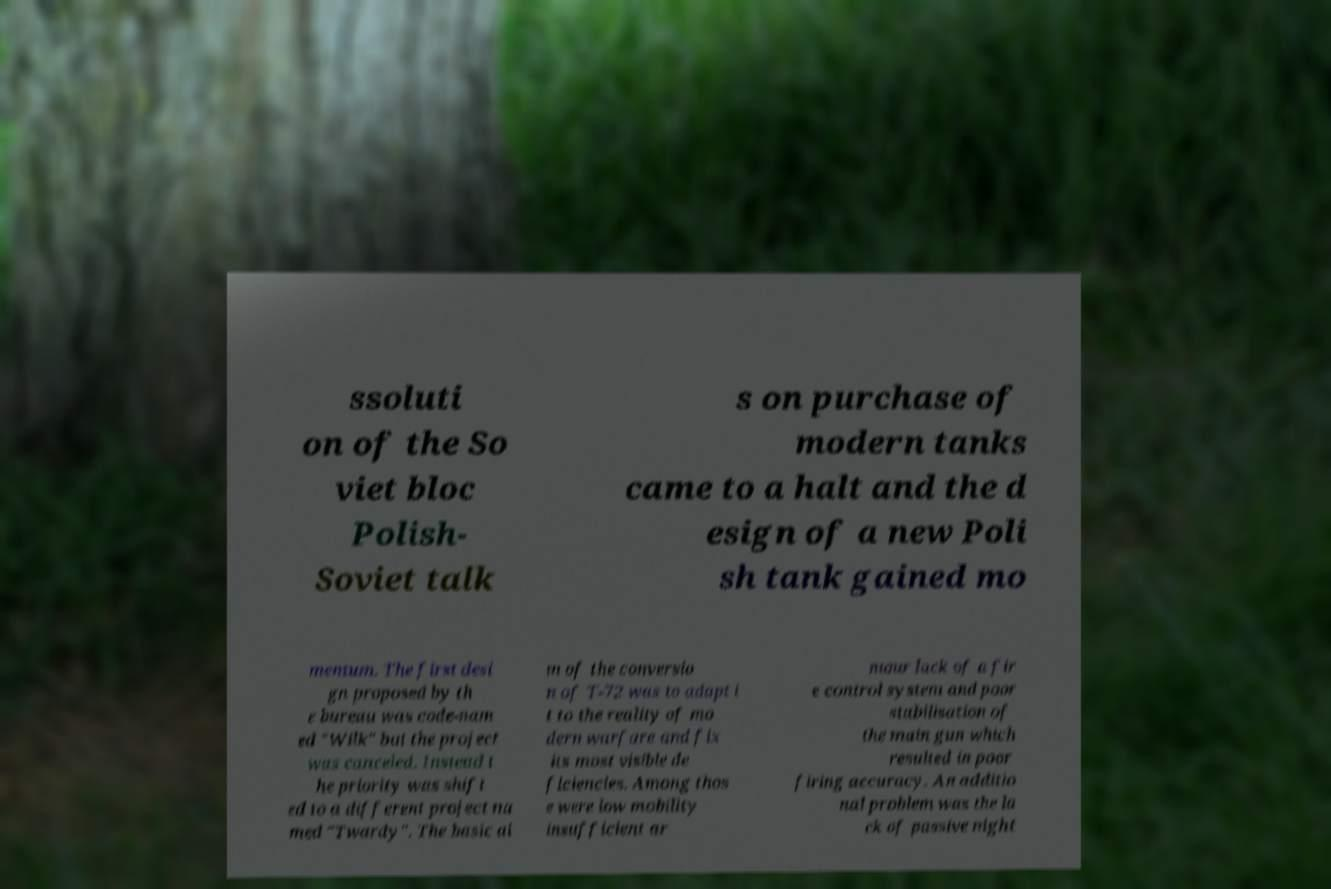Can you accurately transcribe the text from the provided image for me? ssoluti on of the So viet bloc Polish- Soviet talk s on purchase of modern tanks came to a halt and the d esign of a new Poli sh tank gained mo mentum. The first desi gn proposed by th e bureau was code-nam ed "Wilk" but the project was canceled. Instead t he priority was shift ed to a different project na med "Twardy". The basic ai m of the conversio n of T-72 was to adapt i t to the reality of mo dern warfare and fix its most visible de ficiencies. Among thos e were low mobility insufficient ar mour lack of a fir e control system and poor stabilisation of the main gun which resulted in poor firing accuracy. An additio nal problem was the la ck of passive night 